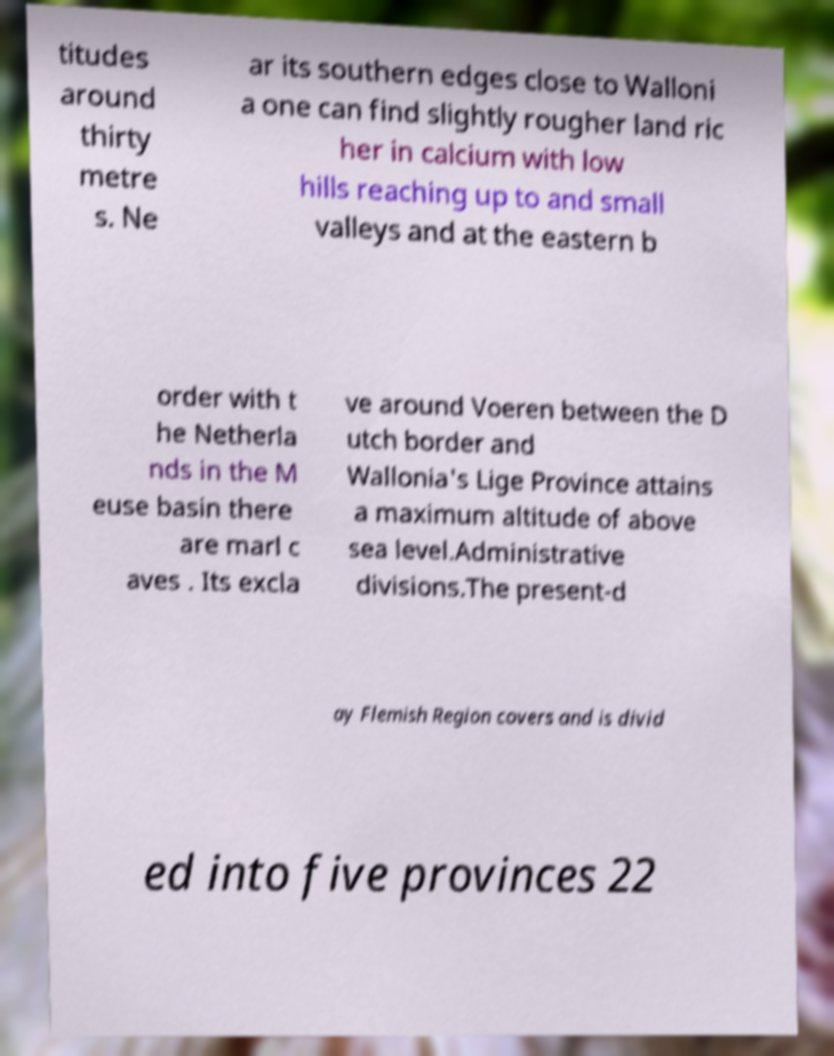Could you assist in decoding the text presented in this image and type it out clearly? titudes around thirty metre s. Ne ar its southern edges close to Walloni a one can find slightly rougher land ric her in calcium with low hills reaching up to and small valleys and at the eastern b order with t he Netherla nds in the M euse basin there are marl c aves . Its excla ve around Voeren between the D utch border and Wallonia's Lige Province attains a maximum altitude of above sea level.Administrative divisions.The present-d ay Flemish Region covers and is divid ed into five provinces 22 